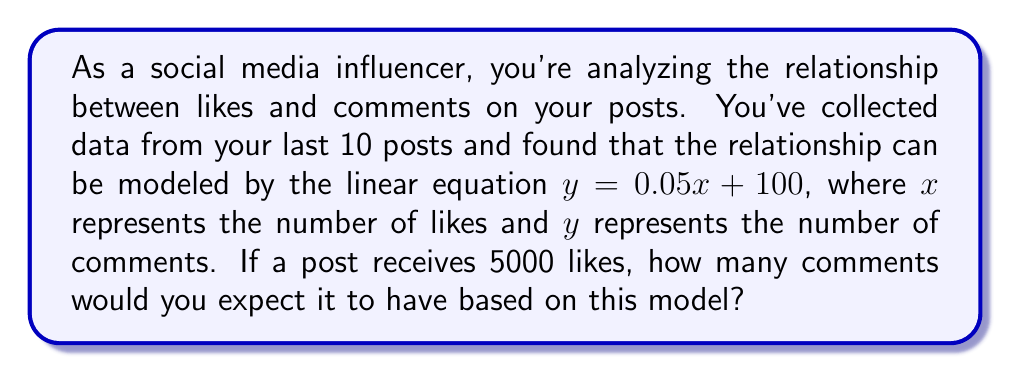Can you answer this question? To solve this problem, we'll follow these steps:

1. Identify the given linear equation:
   $y = 0.05x + 100$

   Where:
   $y$ = number of comments
   $x$ = number of likes

2. We're asked to find the number of comments when there are 5000 likes, so we'll substitute $x = 5000$ into the equation:

   $y = 0.05(5000) + 100$

3. Simplify the right side of the equation:
   $y = 250 + 100$

4. Calculate the final result:
   $y = 350$

Therefore, based on this linear model, a post with 5000 likes would be expected to have 350 comments.
Answer: 350 comments 